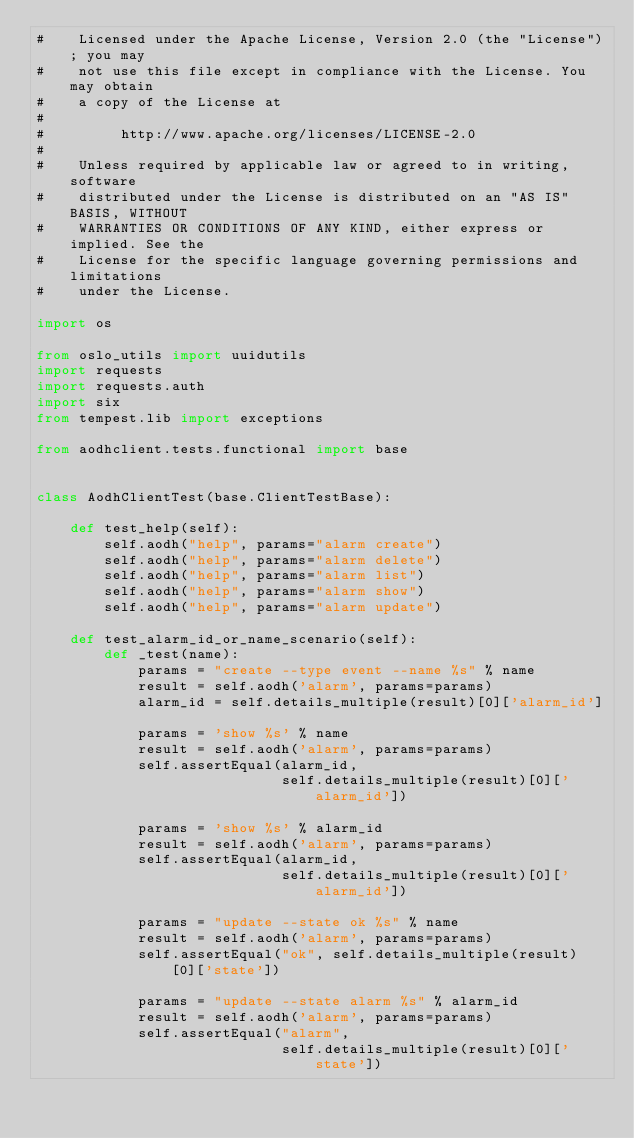<code> <loc_0><loc_0><loc_500><loc_500><_Python_>#    Licensed under the Apache License, Version 2.0 (the "License"); you may
#    not use this file except in compliance with the License. You may obtain
#    a copy of the License at
#
#         http://www.apache.org/licenses/LICENSE-2.0
#
#    Unless required by applicable law or agreed to in writing, software
#    distributed under the License is distributed on an "AS IS" BASIS, WITHOUT
#    WARRANTIES OR CONDITIONS OF ANY KIND, either express or implied. See the
#    License for the specific language governing permissions and limitations
#    under the License.

import os

from oslo_utils import uuidutils
import requests
import requests.auth
import six
from tempest.lib import exceptions

from aodhclient.tests.functional import base


class AodhClientTest(base.ClientTestBase):

    def test_help(self):
        self.aodh("help", params="alarm create")
        self.aodh("help", params="alarm delete")
        self.aodh("help", params="alarm list")
        self.aodh("help", params="alarm show")
        self.aodh("help", params="alarm update")

    def test_alarm_id_or_name_scenario(self):
        def _test(name):
            params = "create --type event --name %s" % name
            result = self.aodh('alarm', params=params)
            alarm_id = self.details_multiple(result)[0]['alarm_id']

            params = 'show %s' % name
            result = self.aodh('alarm', params=params)
            self.assertEqual(alarm_id,
                             self.details_multiple(result)[0]['alarm_id'])

            params = 'show %s' % alarm_id
            result = self.aodh('alarm', params=params)
            self.assertEqual(alarm_id,
                             self.details_multiple(result)[0]['alarm_id'])

            params = "update --state ok %s" % name
            result = self.aodh('alarm', params=params)
            self.assertEqual("ok", self.details_multiple(result)[0]['state'])

            params = "update --state alarm %s" % alarm_id
            result = self.aodh('alarm', params=params)
            self.assertEqual("alarm",
                             self.details_multiple(result)[0]['state'])
</code> 